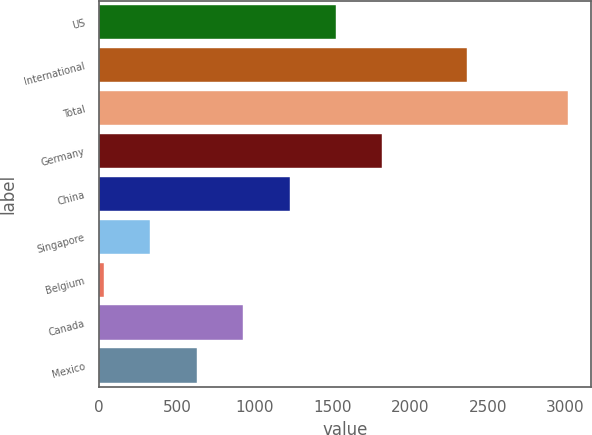<chart> <loc_0><loc_0><loc_500><loc_500><bar_chart><fcel>US<fcel>International<fcel>Total<fcel>Germany<fcel>China<fcel>Singapore<fcel>Belgium<fcel>Canada<fcel>Mexico<nl><fcel>1523.5<fcel>2367<fcel>3017<fcel>1822.2<fcel>1224.8<fcel>328.7<fcel>30<fcel>926.1<fcel>627.4<nl></chart> 